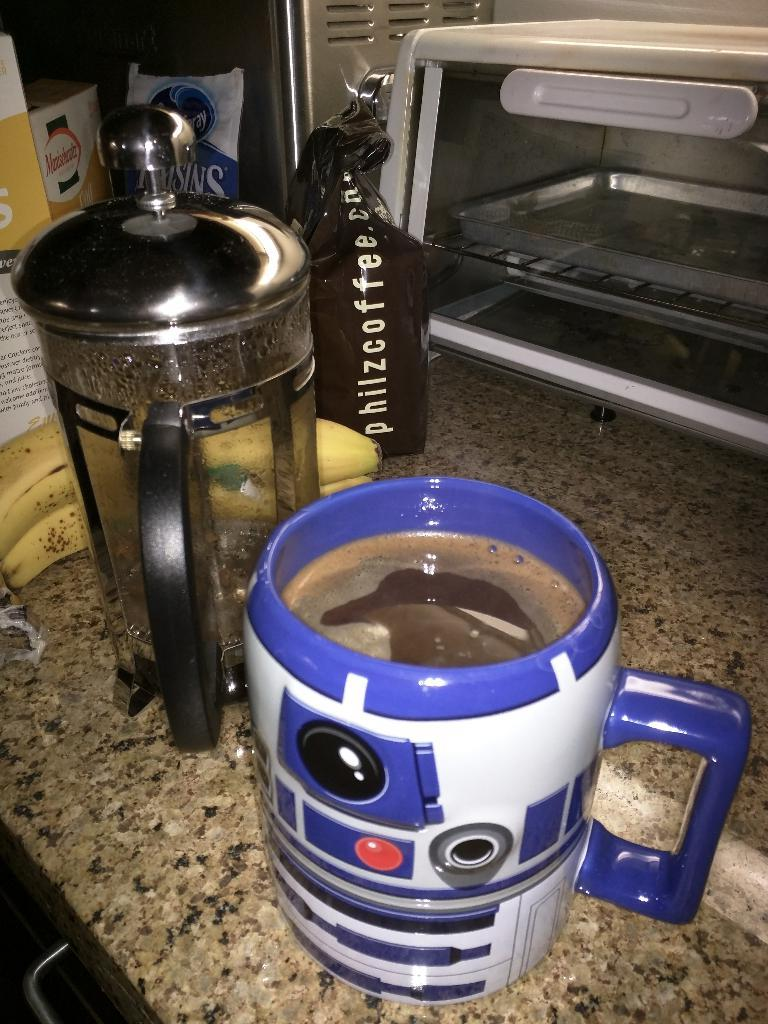<image>
Describe the image concisely. a french press of philz coffee and full mug on a counter 